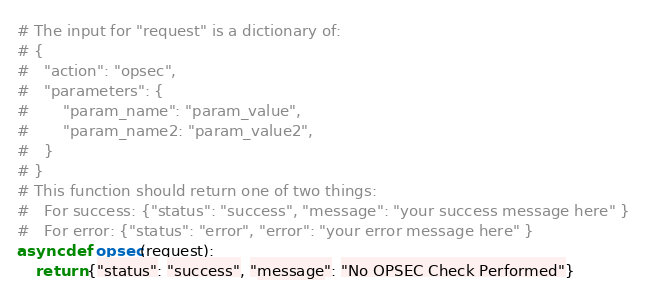<code> <loc_0><loc_0><loc_500><loc_500><_Python_># The input for "request" is a dictionary of:
# {
#   "action": "opsec",
#   "parameters": {
#       "param_name": "param_value",
#       "param_name2: "param_value2",
#   }
# }
# This function should return one of two things:
#   For success: {"status": "success", "message": "your success message here" }
#   For error: {"status": "error", "error": "your error message here" }
async def opsec(request):
    return {"status": "success", "message": "No OPSEC Check Performed"}</code> 